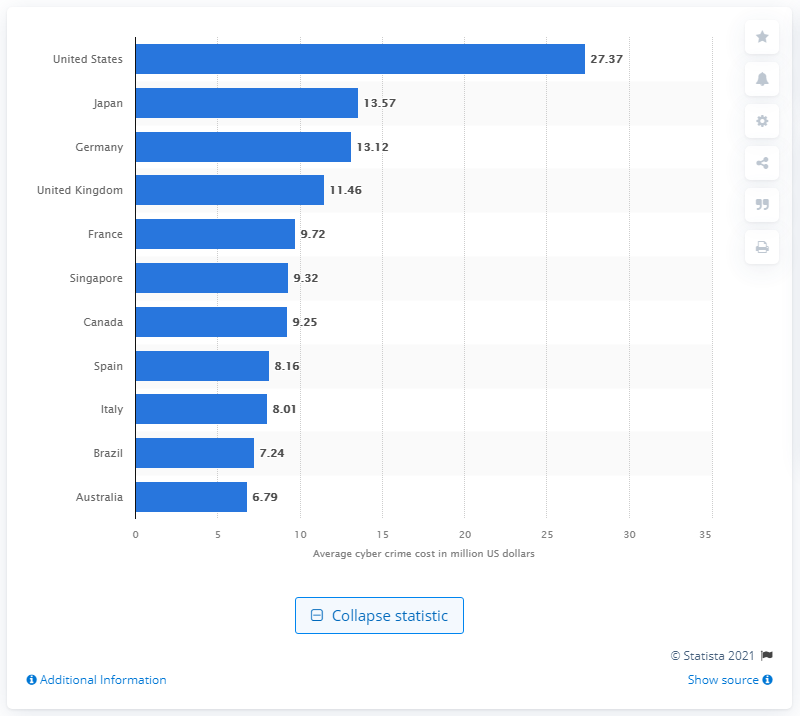Point out several critical features in this image. Japan incurred an average of 13.57 billion dollars in damages per year as a result of attacks on companies. The average annualized cost of cybercrime attacks in the United States in 2018 was approximately $27.37 per household. 